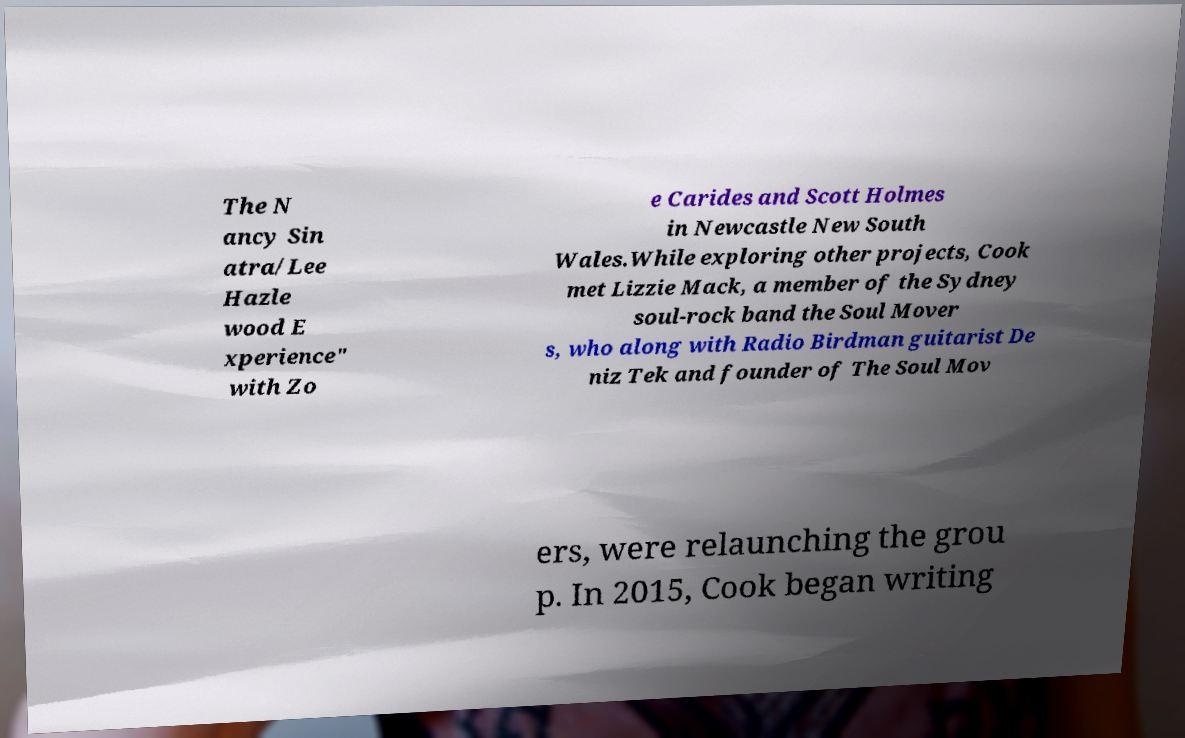Can you accurately transcribe the text from the provided image for me? The N ancy Sin atra/Lee Hazle wood E xperience" with Zo e Carides and Scott Holmes in Newcastle New South Wales.While exploring other projects, Cook met Lizzie Mack, a member of the Sydney soul-rock band the Soul Mover s, who along with Radio Birdman guitarist De niz Tek and founder of The Soul Mov ers, were relaunching the grou p. In 2015, Cook began writing 